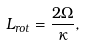Convert formula to latex. <formula><loc_0><loc_0><loc_500><loc_500>L _ { r o t } = \frac { 2 \Omega } { \kappa } ,</formula> 